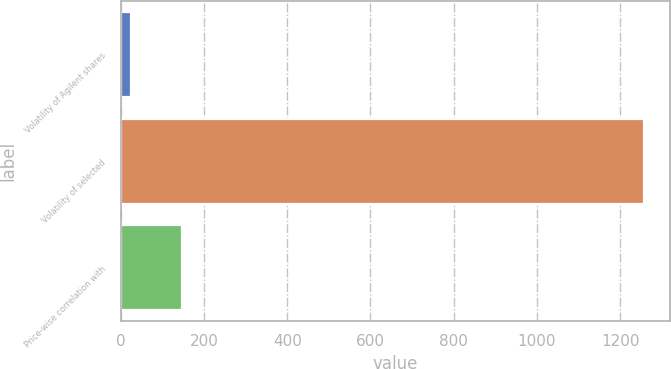Convert chart. <chart><loc_0><loc_0><loc_500><loc_500><bar_chart><fcel>Volatility of Agilent shares<fcel>Volatility of selected<fcel>Price-wise correlation with<nl><fcel>25<fcel>1257<fcel>148.2<nl></chart> 